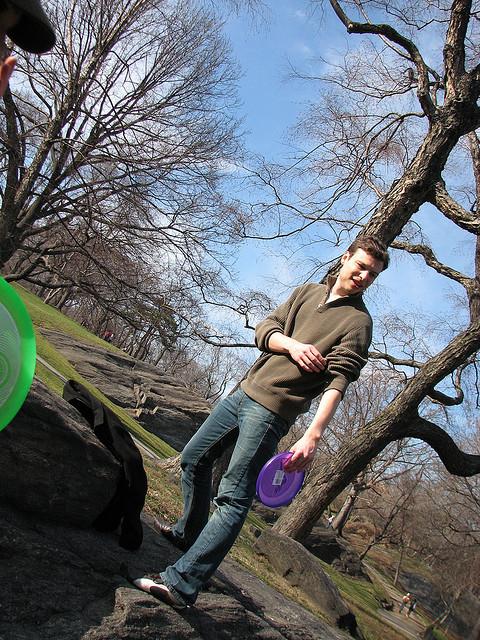What color is the Frisbee?
Write a very short answer. Purple. What color is the frisbee?
Answer briefly. Purple. Was this picture taken on an angle?
Be succinct. Yes. What shape is the frisbee?
Be succinct. Round. 